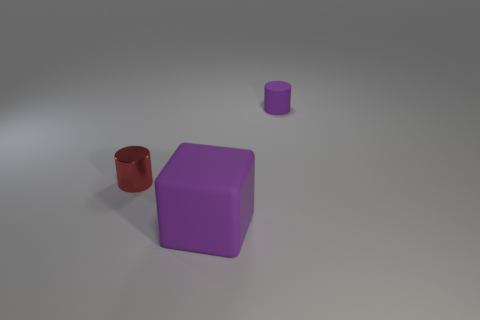Add 2 small red cylinders. How many objects exist? 5 Subtract all cylinders. How many objects are left? 1 Add 3 cubes. How many cubes exist? 4 Subtract 0 gray spheres. How many objects are left? 3 Subtract all small metallic objects. Subtract all metal cylinders. How many objects are left? 1 Add 3 red cylinders. How many red cylinders are left? 4 